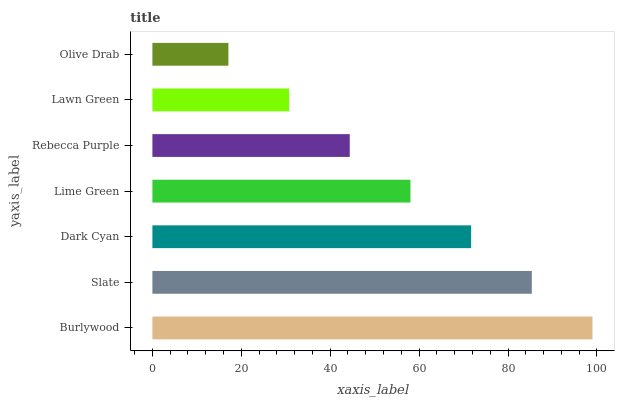Is Olive Drab the minimum?
Answer yes or no. Yes. Is Burlywood the maximum?
Answer yes or no. Yes. Is Slate the minimum?
Answer yes or no. No. Is Slate the maximum?
Answer yes or no. No. Is Burlywood greater than Slate?
Answer yes or no. Yes. Is Slate less than Burlywood?
Answer yes or no. Yes. Is Slate greater than Burlywood?
Answer yes or no. No. Is Burlywood less than Slate?
Answer yes or no. No. Is Lime Green the high median?
Answer yes or no. Yes. Is Lime Green the low median?
Answer yes or no. Yes. Is Olive Drab the high median?
Answer yes or no. No. Is Dark Cyan the low median?
Answer yes or no. No. 